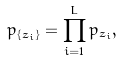Convert formula to latex. <formula><loc_0><loc_0><loc_500><loc_500>p _ { \{ z _ { i } \} } = \prod ^ { L } _ { i = 1 } p _ { z _ { i } } ,</formula> 